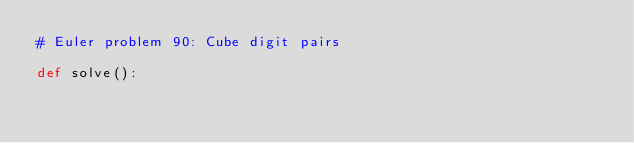Convert code to text. <code><loc_0><loc_0><loc_500><loc_500><_Python_># Euler problem 90: Cube digit pairs

def solve():
    </code> 